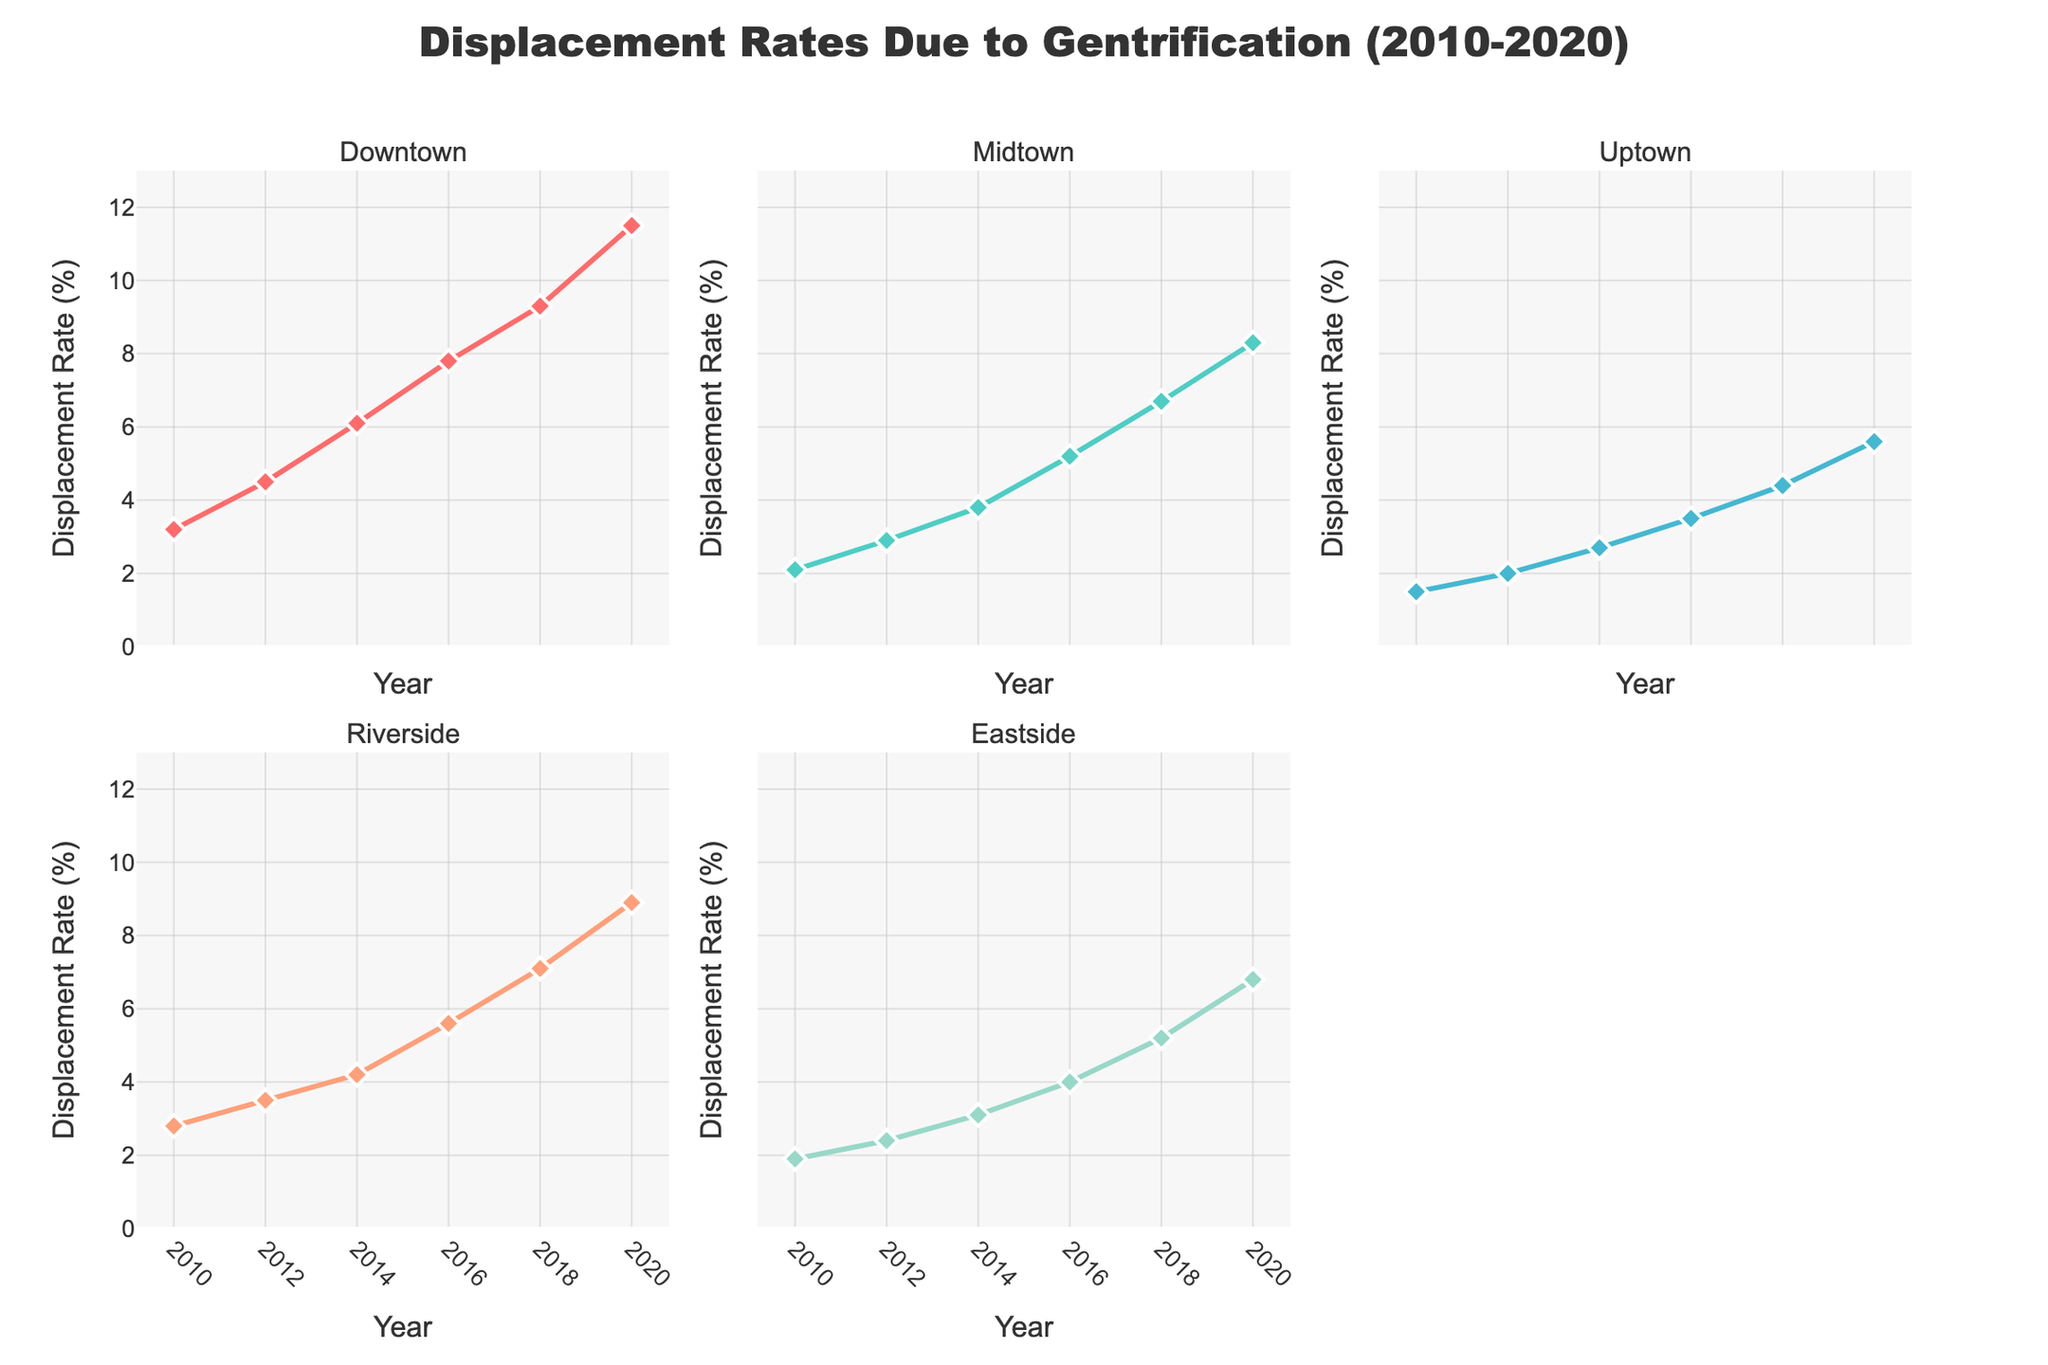What is the overall trend in displacement rates for Downtown from 2010 to 2020? The plot shows the line for Downtown steadily increasing from 3.2% in 2010 to 11.5% in 2020, indicating a continuous rise in displacement rates.
Answer: Continual increase Which part of the city had the lowest displacement rate in 2010? By looking at the initial points of the lines on each subplot, Uptown recorded the lowest displacement rate at 1.5% in 2010.
Answer: Uptown In which year did Riverside experience the most significant increase in displacement rate? Checking the gaps between consecutive data points on the Riverside subplot, the biggest jump is between 2016 (5.6%) and 2018 (7.1%), showing an increase of 1.5%.
Answer: 2018 By how much did the displacement rate in Eastside change from 2010 to 2020? The Eastside's displacement rate goes from 1.9% in 2010 to 6.8% in 2020. The change can be calculated as 6.8% - 1.9% = 4.9%.
Answer: 4.9% Which neighborhood had the highest displacement rate in 2018, and what was it? By comparing the 2018 points across all subplots, Downtown had the highest displacement rate at 9.3%.
Answer: Downtown, 9.3% Compare the displacement rate growth between Downtown and Midtown from 2010 to 2020. Which had a steeper increase? Downtown's rate increased from 3.2% to 11.5%, a rise of 8.3%, whereas Midtown's grew from 2.1% to 8.3%, an increase of 6.2%. Therefore, Downtown had a steeper increase.
Answer: Downtown What was the average displacement rate in Riverside from 2010 to 2020? Add up the rates for Riverside from each year (2.8 + 3.5 + 4.2 + 5.6 + 7.1 + 8.9) and divide by 6. The sum is 32.1%, so the average is 32.1% / 6 ≈ 5.35%.
Answer: 5.35% Which neighborhood showed the least variation in displacement rates across the years? Observing the range of change in each subplot, Uptown's displacement rate increased from 1.5% to 5.6%, a change of 4.1%, which is less than the changes in other neighborhoods' rates.
Answer: Uptown Between 2016 and 2018, which neighborhood had the smallest increase in displacement rate? Subtract the 2016 rate from the 2018 rate for each neighborhood: Downtown (1.5%), Midtown (1.5%), Uptown (0.9%), Riverside (1.5%), Eastside (1.2%). Uptown had the smallest increase of 0.9%.
Answer: Uptown 